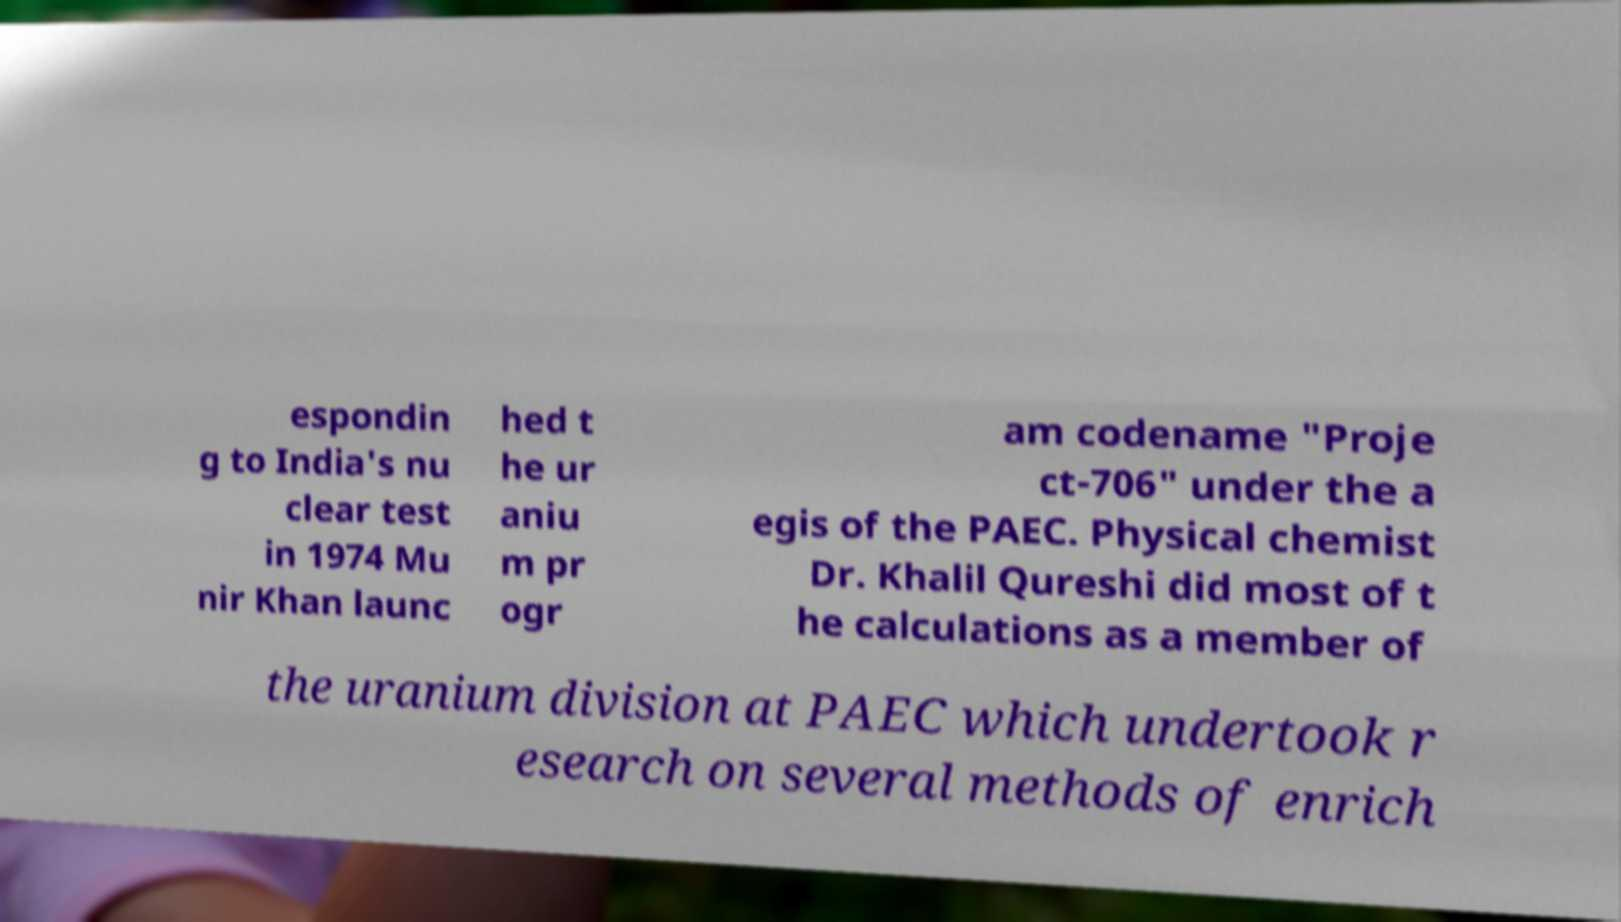Could you extract and type out the text from this image? espondin g to India's nu clear test in 1974 Mu nir Khan launc hed t he ur aniu m pr ogr am codename "Proje ct-706" under the a egis of the PAEC. Physical chemist Dr. Khalil Qureshi did most of t he calculations as a member of the uranium division at PAEC which undertook r esearch on several methods of enrich 